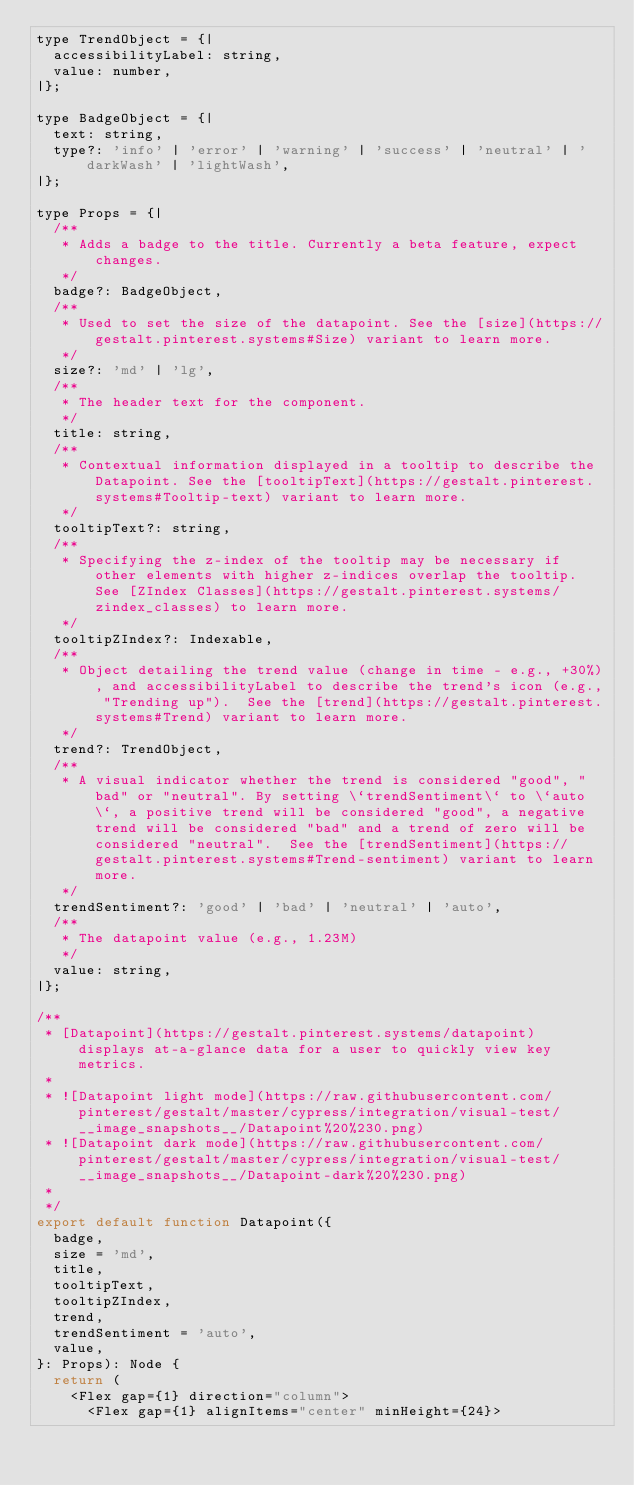Convert code to text. <code><loc_0><loc_0><loc_500><loc_500><_JavaScript_>type TrendObject = {|
  accessibilityLabel: string,
  value: number,
|};

type BadgeObject = {|
  text: string,
  type?: 'info' | 'error' | 'warning' | 'success' | 'neutral' | 'darkWash' | 'lightWash',
|};

type Props = {|
  /**
   * Adds a badge to the title. Currently a beta feature, expect changes.
   */
  badge?: BadgeObject,
  /**
   * Used to set the size of the datapoint. See the [size](https://gestalt.pinterest.systems#Size) variant to learn more.
   */
  size?: 'md' | 'lg',
  /**
   * The header text for the component.
   */
  title: string,
  /**
   * Contextual information displayed in a tooltip to describe the Datapoint. See the [tooltipText](https://gestalt.pinterest.systems#Tooltip-text) variant to learn more.
   */
  tooltipText?: string,
  /**
   * Specifying the z-index of the tooltip may be necessary if other elements with higher z-indices overlap the tooltip. See [ZIndex Classes](https://gestalt.pinterest.systems/zindex_classes) to learn more.
   */
  tooltipZIndex?: Indexable,
  /**
   * Object detailing the trend value (change in time - e.g., +30%), and accessibilityLabel to describe the trend's icon (e.g., "Trending up").  See the [trend](https://gestalt.pinterest.systems#Trend) variant to learn more.
   */
  trend?: TrendObject,
  /**
   * A visual indicator whether the trend is considered "good", "bad" or "neutral". By setting \`trendSentiment\` to \`auto\`, a positive trend will be considered "good", a negative trend will be considered "bad" and a trend of zero will be considered "neutral".  See the [trendSentiment](https://gestalt.pinterest.systems#Trend-sentiment) variant to learn more.
   */
  trendSentiment?: 'good' | 'bad' | 'neutral' | 'auto',
  /**
   * The datapoint value (e.g., 1.23M)
   */
  value: string,
|};

/**
 * [Datapoint](https://gestalt.pinterest.systems/datapoint) displays at-a-glance data for a user to quickly view key metrics.
 *
 * ![Datapoint light mode](https://raw.githubusercontent.com/pinterest/gestalt/master/cypress/integration/visual-test/__image_snapshots__/Datapoint%20%230.png)
 * ![Datapoint dark mode](https://raw.githubusercontent.com/pinterest/gestalt/master/cypress/integration/visual-test/__image_snapshots__/Datapoint-dark%20%230.png)
 *
 */
export default function Datapoint({
  badge,
  size = 'md',
  title,
  tooltipText,
  tooltipZIndex,
  trend,
  trendSentiment = 'auto',
  value,
}: Props): Node {
  return (
    <Flex gap={1} direction="column">
      <Flex gap={1} alignItems="center" minHeight={24}></code> 